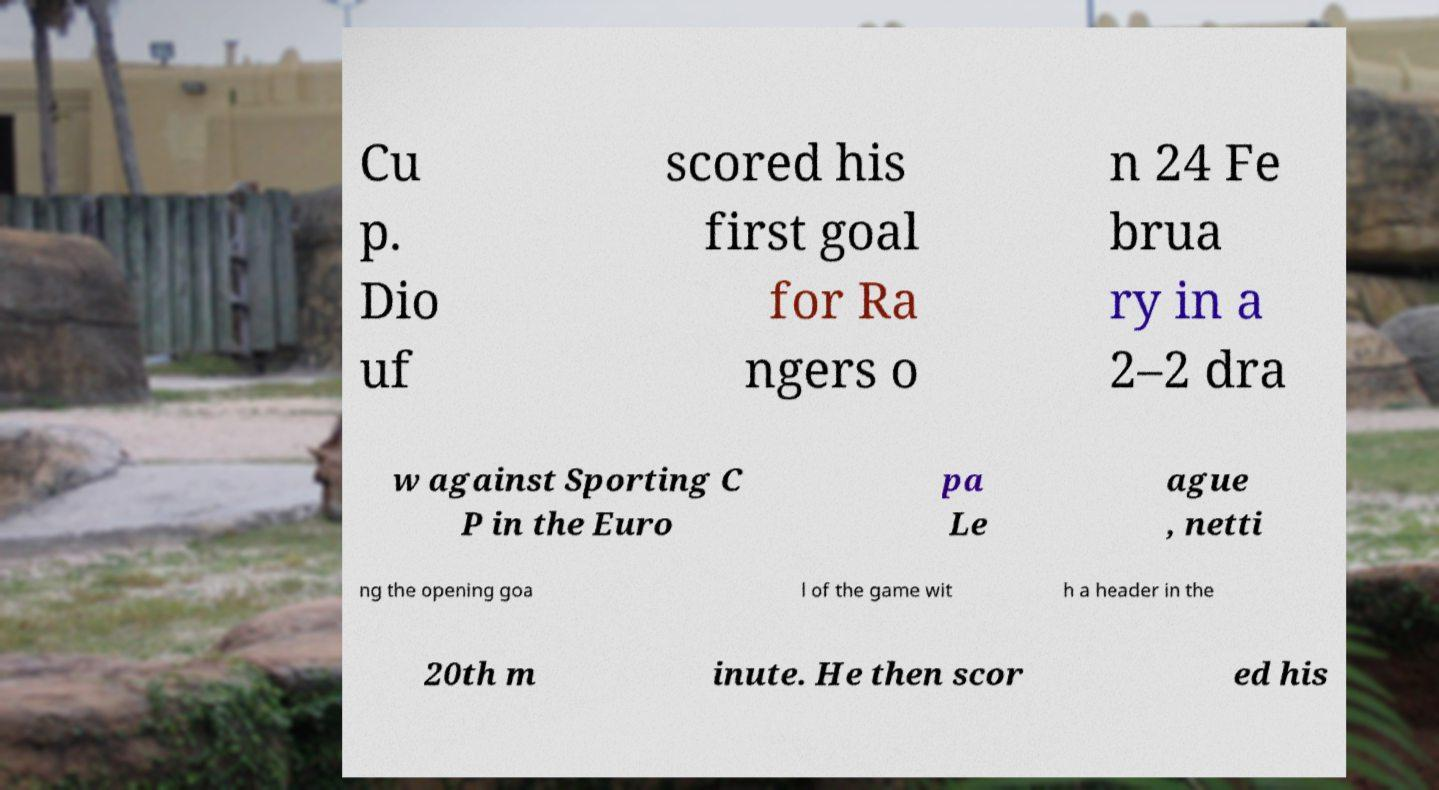There's text embedded in this image that I need extracted. Can you transcribe it verbatim? Cu p. Dio uf scored his first goal for Ra ngers o n 24 Fe brua ry in a 2–2 dra w against Sporting C P in the Euro pa Le ague , netti ng the opening goa l of the game wit h a header in the 20th m inute. He then scor ed his 